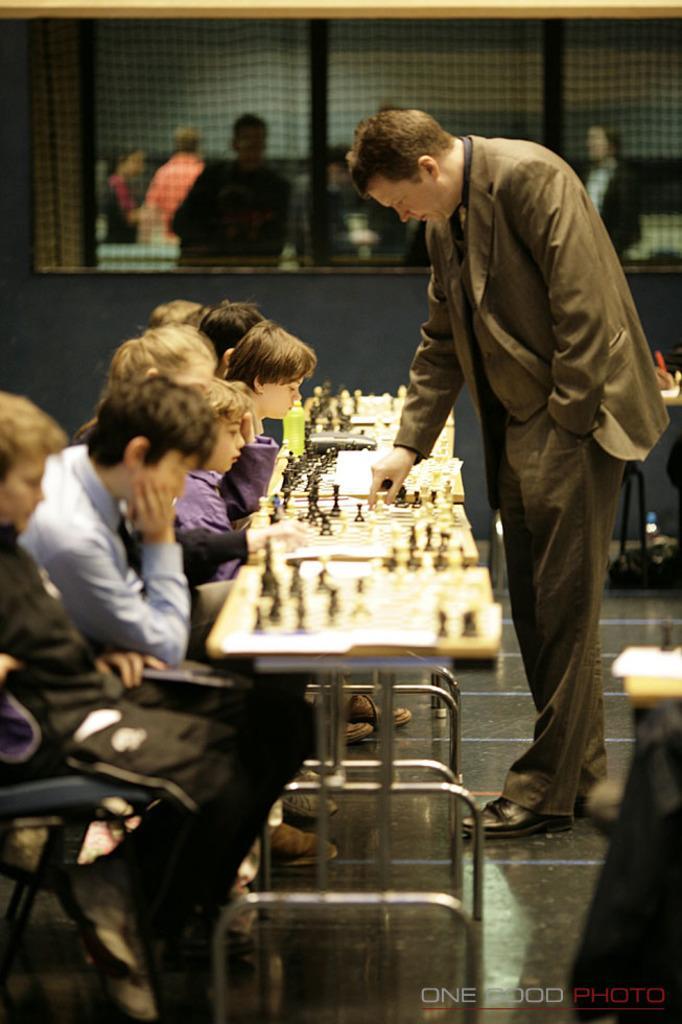Please provide a concise description of this image. In this image there are group of people sitting in chair, and in table there are chess boards , chess coins , there is a man standing near the table and in back ground there are group of people. 